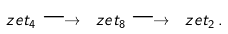Convert formula to latex. <formula><loc_0><loc_0><loc_500><loc_500>\ z e t _ { 4 } \longrightarrow \ z e t _ { 8 } \longrightarrow \ z e t _ { 2 } \, .</formula> 